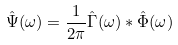<formula> <loc_0><loc_0><loc_500><loc_500>\hat { \Psi } ( \omega ) = \frac { 1 } { 2 \pi } \hat { \Gamma } ( \omega ) \ast \hat { \Phi } ( \omega )</formula> 